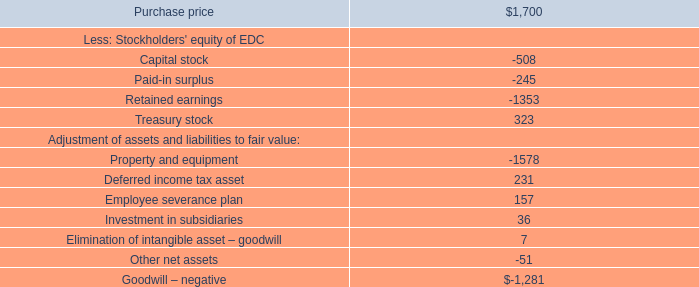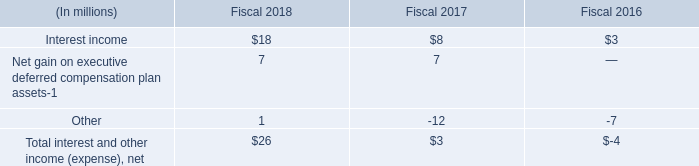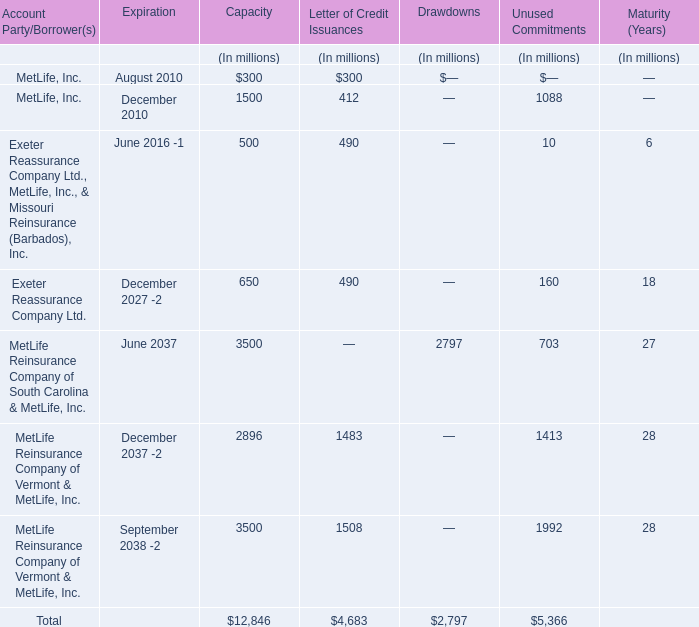what was the total price for the kmr power corporation purchase in millions? 
Computations: (64 + 245)
Answer: 309.0. 